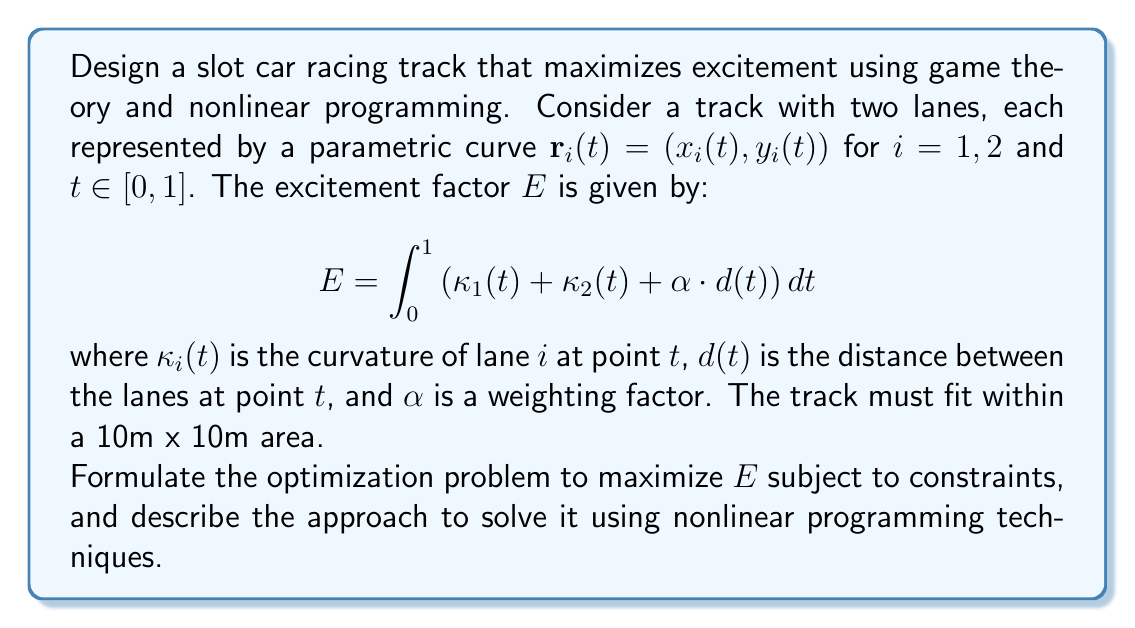Can you answer this question? To solve this optimization problem, we'll follow these steps:

1) Formulate the objective function:
   The excitement factor $E$ is our objective function to be maximized.

2) Define the design variables:
   The design variables are the control points for the parametric curves $\mathbf{r}_1(t)$ and $\mathbf{r}_2(t)$. Let's assume we use cubic splines, so we have control points $(x_{1,j}, y_{1,j})$ and $(x_{2,j}, y_{2,j})$ for $j = 0, 1, ..., n$.

3) Express constraints:
   a) Boundary constraints: $0 \leq x_{i,j}, y_{i,j} \leq 10$ for all $i, j$
   b) Closed loop: $(x_{i,0}, y_{i,0}) = (x_{i,n}, y_{i,n})$ for $i = 1, 2$
   c) Minimum distance between lanes: $d(t) \geq d_{min}$ for all $t$
   d) Maximum curvature: $\kappa_i(t) \leq \kappa_{max}$ for all $t$ and $i = 1, 2$

4) Formulate the nonlinear programming problem:
   
   $$\begin{align*}
   \text{maximize} \quad & E = \int_0^1 \left(\kappa_1(t) + \kappa_2(t) + \alpha \cdot d(t)\right) dt \\
   \text{subject to} \quad & 0 \leq x_{i,j}, y_{i,j} \leq 10 \quad \forall i, j \\
   & (x_{i,0}, y_{i,0}) = (x_{i,n}, y_{i,n}) \quad \text{for } i = 1, 2 \\
   & d(t) \geq d_{min} \quad \forall t \in [0, 1] \\
   & \kappa_i(t) \leq \kappa_{max} \quad \forall t \in [0, 1], i = 1, 2
   \end{align*}$$

5) Solve using nonlinear programming techniques:
   a) Discretize the integral in the objective function using numerical integration.
   b) Approximate the continuous constraints on $d(t)$ and $\kappa_i(t)$ by checking at a finite number of points.
   c) Use a nonlinear optimization solver such as Sequential Quadratic Programming (SQP) or Interior Point Method (IPM) to solve the problem.

6) Game theory aspect:
   Consider the problem as a two-player game where each lane tries to maximize its own excitement. This leads to a Nash equilibrium where neither lane can unilaterally improve its excitement. Solve this using techniques like the best response dynamics or simultaneous optimization.

7) Iterative process:
   a) Start with an initial guess for the track design.
   b) Solve the optimization problem.
   c) Analyze the results and adjust parameters if necessary.
   d) Repeat until a satisfactory design is achieved.

This approach combines nonlinear programming to optimize the track design with game theory to ensure a balanced and exciting experience for both lanes.
Answer: Maximize $E = \int_0^1 (\kappa_1(t) + \kappa_2(t) + \alpha d(t)) dt$ subject to boundary, closure, distance, and curvature constraints; solve using discretized NLP and game theory. 